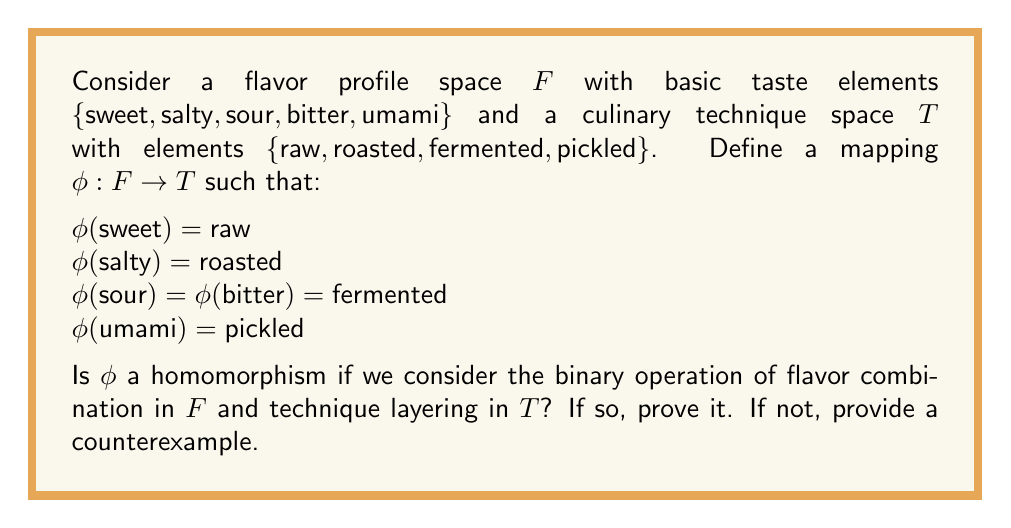What is the answer to this math problem? To determine if $\phi$ is a homomorphism, we need to check if it preserves the structure between the two spaces. In this case, we need to verify if for any two elements $a, b \in F$, the following holds:

$$\phi(a * b) = \phi(a) \circ \phi(b)$$

where $*$ represents flavor combination in $F$ and $\circ$ represents technique layering in $T$.

Let's consider a counterexample:

Take $a = \text{sweet}$ and $b = \text{salty}$

$\phi(\text{sweet} * \text{salty}) = \phi(\text{sweet-salty combination})$

In culinary terms, a sweet-salty combination often results in a complex umami flavor. So:

$\phi(\text{sweet} * \text{salty}) = \phi(\text{umami}) = \text{pickled}$

However,

$\phi(\text{sweet}) \circ \phi(\text{salty}) = \text{raw} \circ \text{roasted}$

In culinary techniques, applying raw and roasted techniques in sequence doesn't typically result in a pickled product.

Therefore, $\phi(\text{sweet} * \text{salty}) \neq \phi(\text{sweet}) \circ \phi(\text{salty})$

This counterexample shows that $\phi$ does not preserve the structure between $F$ and $T$ for all elements, and thus is not a homomorphism.
Answer: No, $\phi$ is not a homomorphism. A counterexample is provided with $a = \text{sweet}$ and $b = \text{salty}$, where $\phi(\text{sweet} * \text{salty}) \neq \phi(\text{sweet}) \circ \phi(\text{salty})$. 